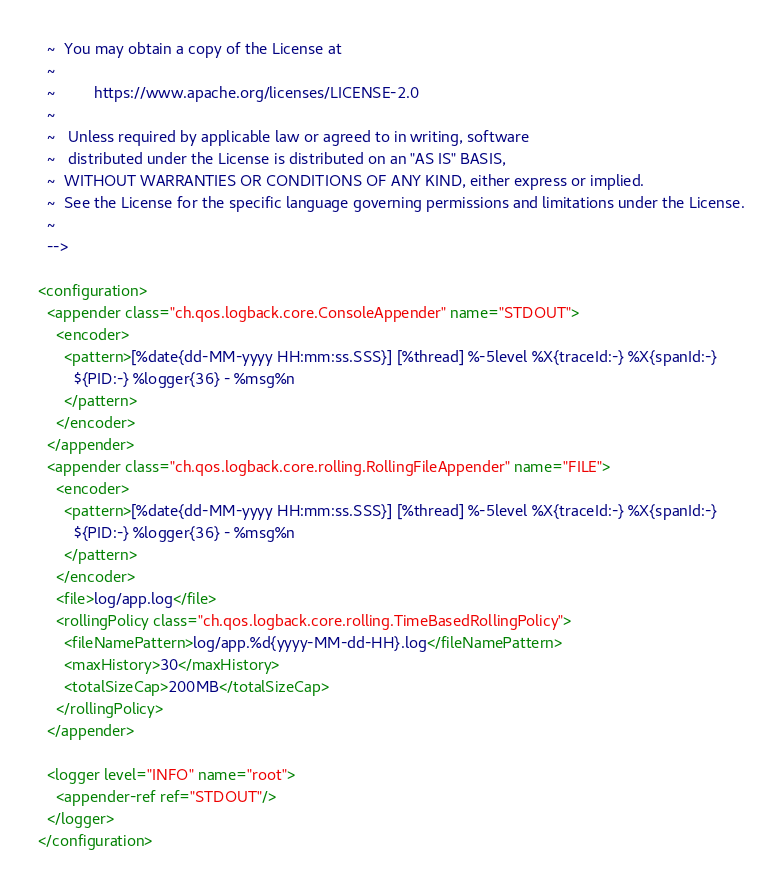Convert code to text. <code><loc_0><loc_0><loc_500><loc_500><_XML_>  ~  You may obtain a copy of the License at
  ~
  ~         https://www.apache.org/licenses/LICENSE-2.0
  ~
  ~   Unless required by applicable law or agreed to in writing, software
  ~   distributed under the License is distributed on an "AS IS" BASIS,
  ~  WITHOUT WARRANTIES OR CONDITIONS OF ANY KIND, either express or implied.
  ~  See the License for the specific language governing permissions and limitations under the License.
  ~
  -->

<configuration>
  <appender class="ch.qos.logback.core.ConsoleAppender" name="STDOUT">
    <encoder>
      <pattern>[%date{dd-MM-yyyy HH:mm:ss.SSS}] [%thread] %-5level %X{traceId:-} %X{spanId:-}
        ${PID:-} %logger{36} - %msg%n
      </pattern>
    </encoder>
  </appender>
  <appender class="ch.qos.logback.core.rolling.RollingFileAppender" name="FILE">
    <encoder>
      <pattern>[%date{dd-MM-yyyy HH:mm:ss.SSS}] [%thread] %-5level %X{traceId:-} %X{spanId:-}
        ${PID:-} %logger{36} - %msg%n
      </pattern>
    </encoder>
    <file>log/app.log</file>
    <rollingPolicy class="ch.qos.logback.core.rolling.TimeBasedRollingPolicy">
      <fileNamePattern>log/app.%d{yyyy-MM-dd-HH}.log</fileNamePattern>
      <maxHistory>30</maxHistory>
      <totalSizeCap>200MB</totalSizeCap>
    </rollingPolicy>
  </appender>

  <logger level="INFO" name="root">
    <appender-ref ref="STDOUT"/>
  </logger>
</configuration></code> 